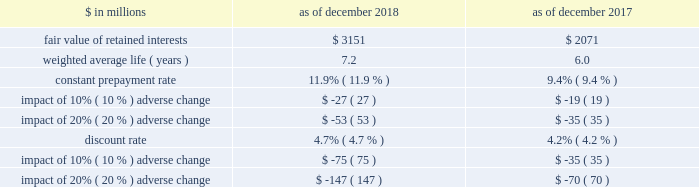The goldman sachs group , inc .
And subsidiaries notes to consolidated financial statements 2030 purchased interests represent senior and subordinated interests , purchased in connection with secondary market-making activities , in securitization entities in which the firm also holds retained interests .
2030 substantially all of the total outstanding principal amount and total retained interests relate to securitizations during 2014 and thereafter as of december 2018 , and relate to securitizations during 2012 and thereafter as of december 2017 .
2030 the fair value of retained interests was $ 3.28 billion as of december 2018 and $ 2.13 billion as of december 2017 .
In addition to the interests in the table above , the firm had other continuing involvement in the form of derivative transactions and commitments with certain nonconsolidated vies .
The carrying value of these derivatives and commitments was a net asset of $ 75 million as of december 2018 and $ 86 million as of december 2017 , and the notional amount of these derivatives and commitments was $ 1.09 billion as of december 2018 and $ 1.26 billion as of december 2017 .
The notional amounts of these derivatives and commitments are included in maximum exposure to loss in the nonconsolidated vie table in note 12 .
The table below presents information about the weighted average key economic assumptions used in measuring the fair value of mortgage-backed retained interests. .
In the table above : 2030 amounts do not reflect the benefit of other financial instruments that are held to mitigate risks inherent in these retained interests .
2030 changes in fair value based on an adverse variation in assumptions generally cannot be extrapolated because the relationship of the change in assumptions to the change in fair value is not usually linear .
2030 the impact of a change in a particular assumption is calculated independently of changes in any other assumption .
In practice , simultaneous changes in assumptions might magnify or counteract the sensitivities disclosed above .
2030 the constant prepayment rate is included only for positions for which it is a key assumption in the determination of fair value .
2030 the discount rate for retained interests that relate to u.s .
Government agency-issued collateralized mortgage obligations does not include any credit loss .
Expected credit loss assumptions are reflected in the discount rate for the remainder of retained interests .
The firm has other retained interests not reflected in the table above with a fair value of $ 133 million and a weighted average life of 4.2 years as of december 2018 , and a fair value of $ 56 million and a weighted average life of 4.5 years as of december 2017 .
Due to the nature and fair value of certain of these retained interests , the weighted average assumptions for constant prepayment and discount rates and the related sensitivity to adverse changes are not meaningful as of both december 2018 and december 2017 .
The firm 2019s maximum exposure to adverse changes in the value of these interests is the carrying value of $ 133 million as of december 2018 and $ 56 million as of december 2017 .
Note 12 .
Variable interest entities a variable interest in a vie is an investment ( e.g. , debt or equity ) or other interest ( e.g. , derivatives or loans and lending commitments ) that will absorb portions of the vie 2019s expected losses and/or receive portions of the vie 2019s expected residual returns .
The firm 2019s variable interests in vies include senior and subordinated debt ; loans and lending commitments ; limited and general partnership interests ; preferred and common equity ; derivatives that may include foreign currency , equity and/or credit risk ; guarantees ; and certain of the fees the firm receives from investment funds .
Certain interest rate , foreign currency and credit derivatives the firm enters into with vies are not variable interests because they create , rather than absorb , risk .
Vies generally finance the purchase of assets by issuing debt and equity securities that are either collateralized by or indexed to the assets held by the vie .
The debt and equity securities issued by a vie may include tranches of varying levels of subordination .
The firm 2019s involvement with vies includes securitization of financial assets , as described in note 11 , and investments in and loans to other types of vies , as described below .
See note 11 for further information about securitization activities , including the definition of beneficial interests .
See note 3 for the firm 2019s consolidation policies , including the definition of a vie .
Goldman sachs 2018 form 10-k 149 .
What was the change in fair value of retained interests in billions as of december 2018 and december 2017? 
Computations: (3.28 - 2.13)
Answer: 1.15. 